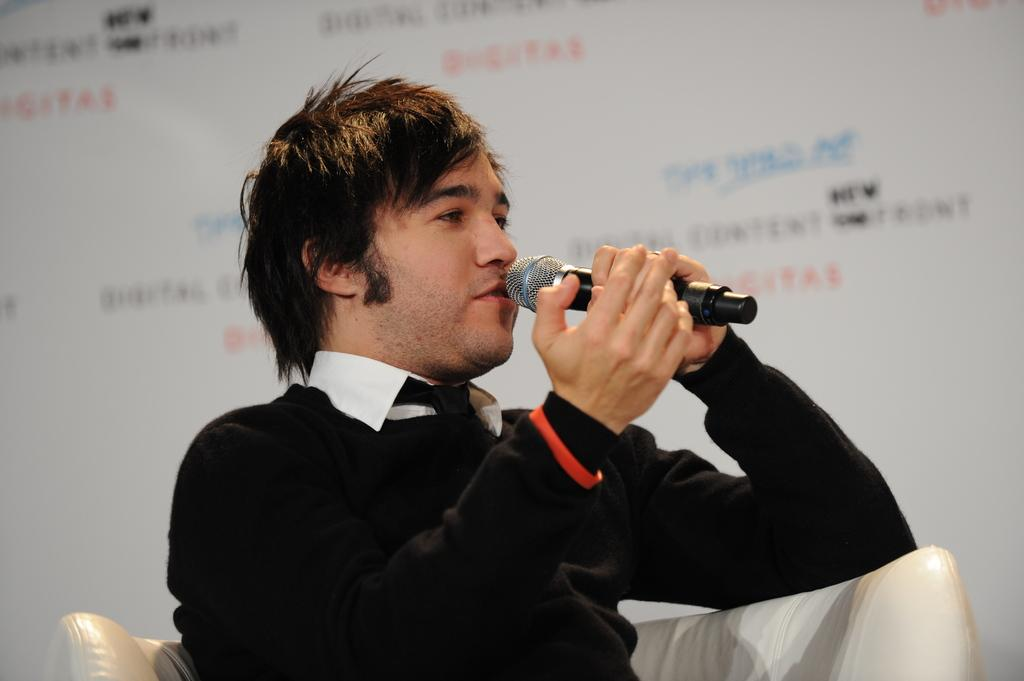What is the main subject of the image? There is a person in the image. What is the person wearing? The person is wearing a black t-shirt. What object is the person holding? The person is holding a microphone. What color is the background of the image? The background of the image is white. What type of crayon is the person using to write on the shoes in the image? There is no crayon or shoes present in the image, and therefore no such activity can be observed. 